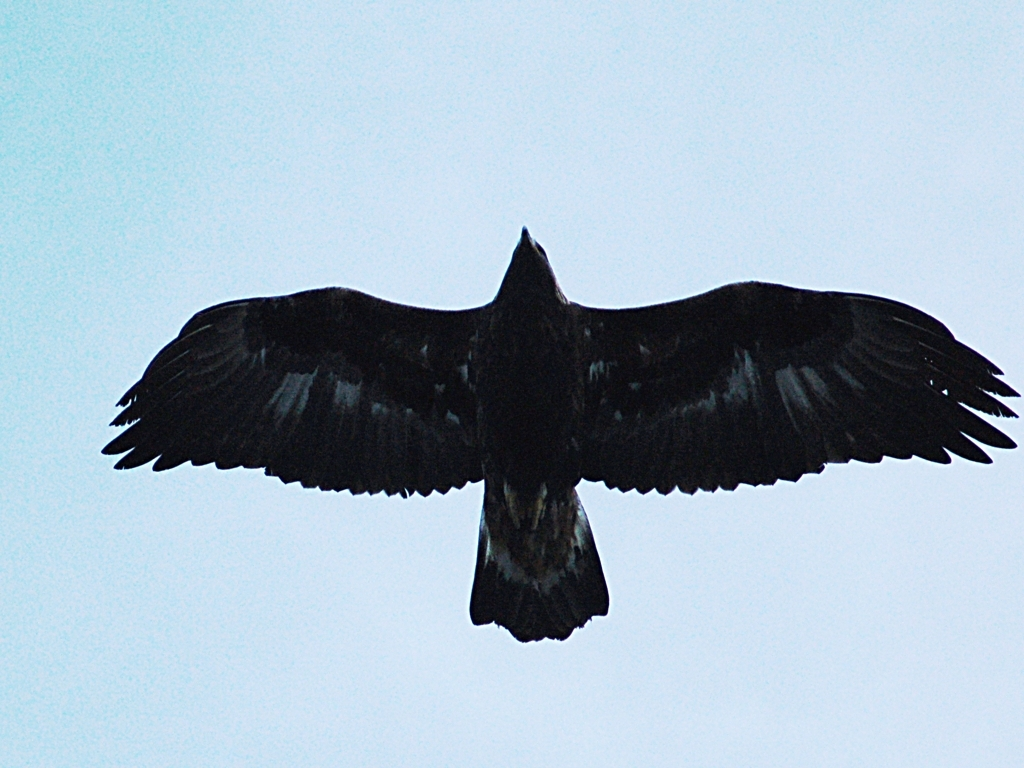Can you describe the flying technique the bird is using? The bird is soaring, which is a flight mode relying on thermal columns of air to maintain altitude without the need for flapping its wings frequently. This energy-efficient method is characteristic of large birds of prey. Why is this technique advantageous for the bird? Soaring allows the bird to conserve energy while traveling long distances or when searching for food. It also provides a good vantage point for spotting potential prey from above without exerting much effort. 